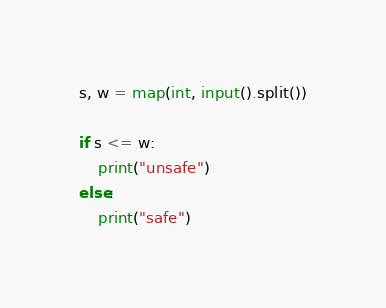Convert code to text. <code><loc_0><loc_0><loc_500><loc_500><_Python_>s, w = map(int, input().split())

if s <= w:
    print("unsafe")
else:
    print("safe")</code> 